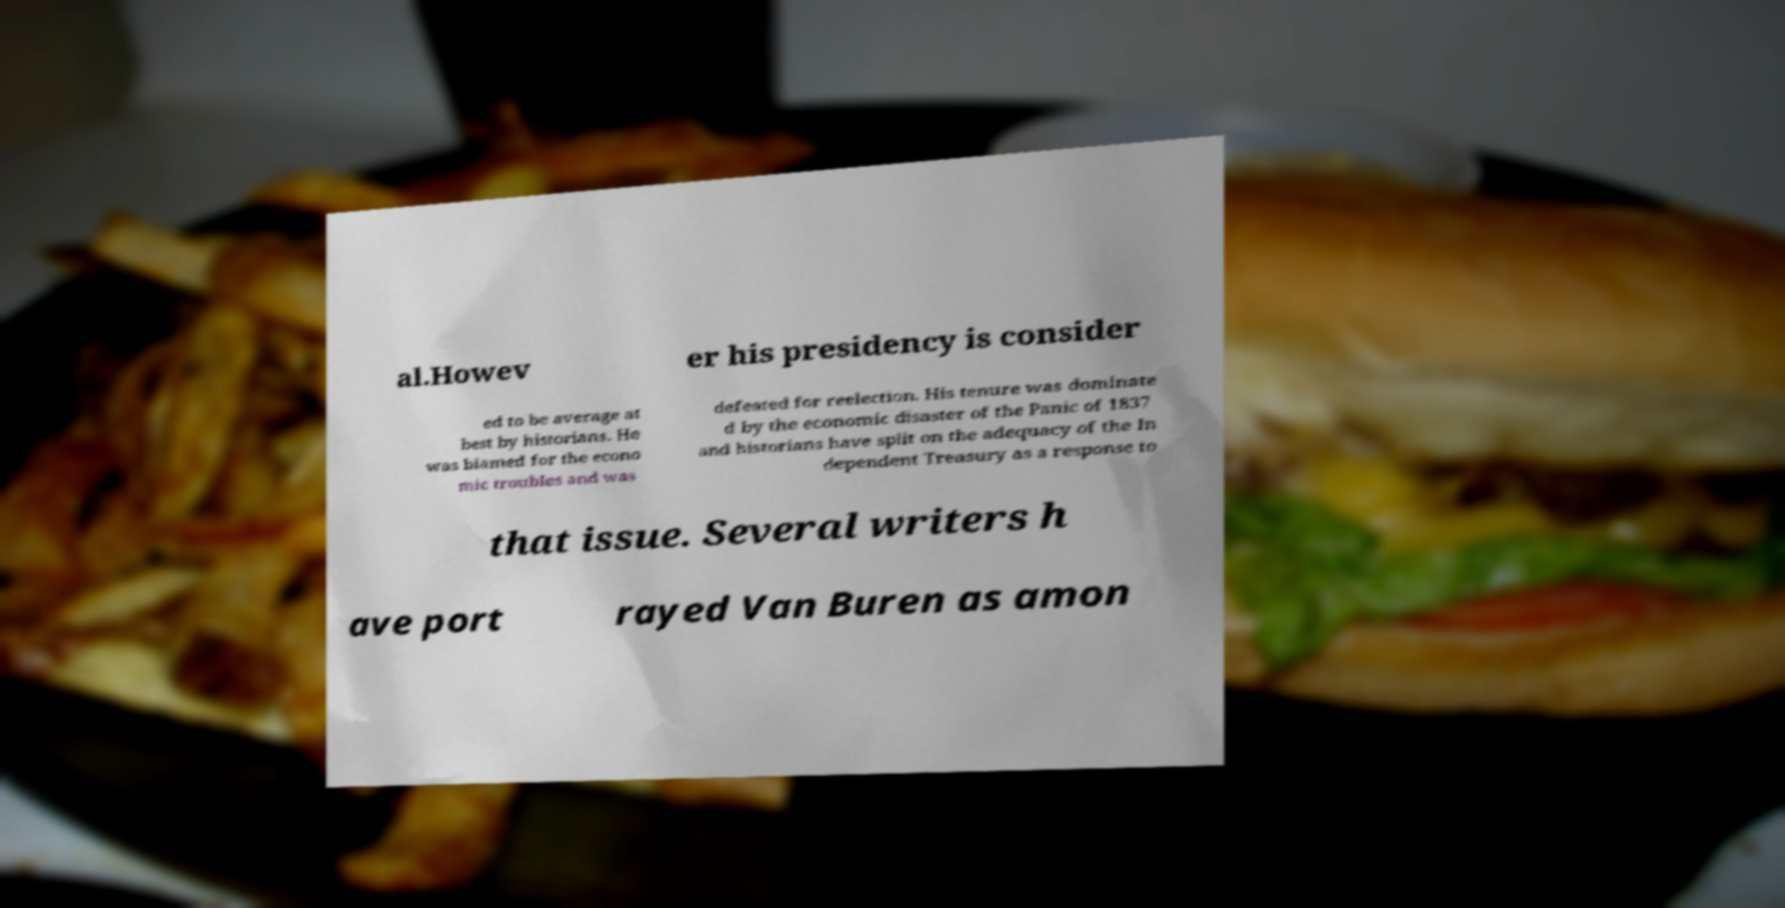There's text embedded in this image that I need extracted. Can you transcribe it verbatim? al.Howev er his presidency is consider ed to be average at best by historians. He was blamed for the econo mic troubles and was defeated for reelection. His tenure was dominate d by the economic disaster of the Panic of 1837 and historians have split on the adequacy of the In dependent Treasury as a response to that issue. Several writers h ave port rayed Van Buren as amon 